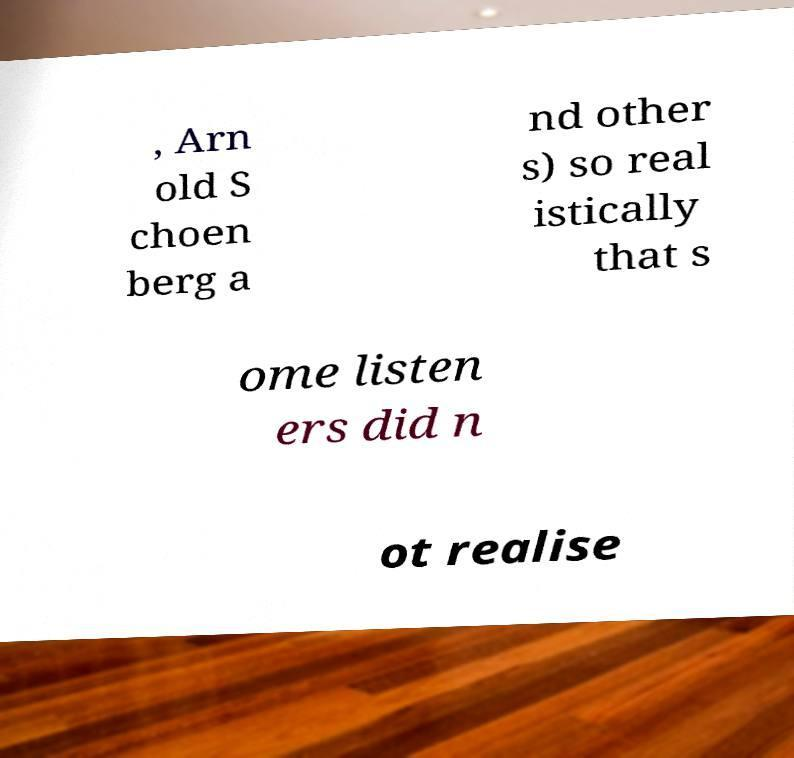Can you read and provide the text displayed in the image?This photo seems to have some interesting text. Can you extract and type it out for me? , Arn old S choen berg a nd other s) so real istically that s ome listen ers did n ot realise 